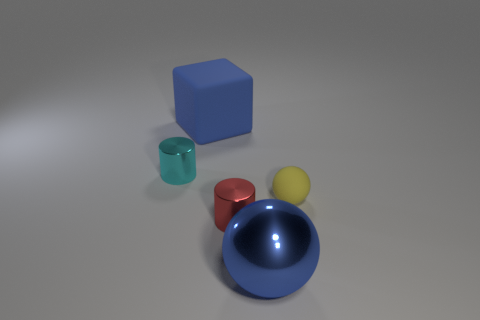Subtract 1 balls. How many balls are left? 1 Add 3 large blue matte blocks. How many large blue matte blocks are left? 4 Add 1 yellow spheres. How many yellow spheres exist? 2 Add 3 gray matte cylinders. How many objects exist? 8 Subtract all cyan cylinders. How many cylinders are left? 1 Subtract 0 brown spheres. How many objects are left? 5 Subtract all cylinders. How many objects are left? 3 Subtract all green spheres. Subtract all cyan blocks. How many spheres are left? 2 Subtract all gray cylinders. How many yellow spheres are left? 1 Subtract all large red blocks. Subtract all balls. How many objects are left? 3 